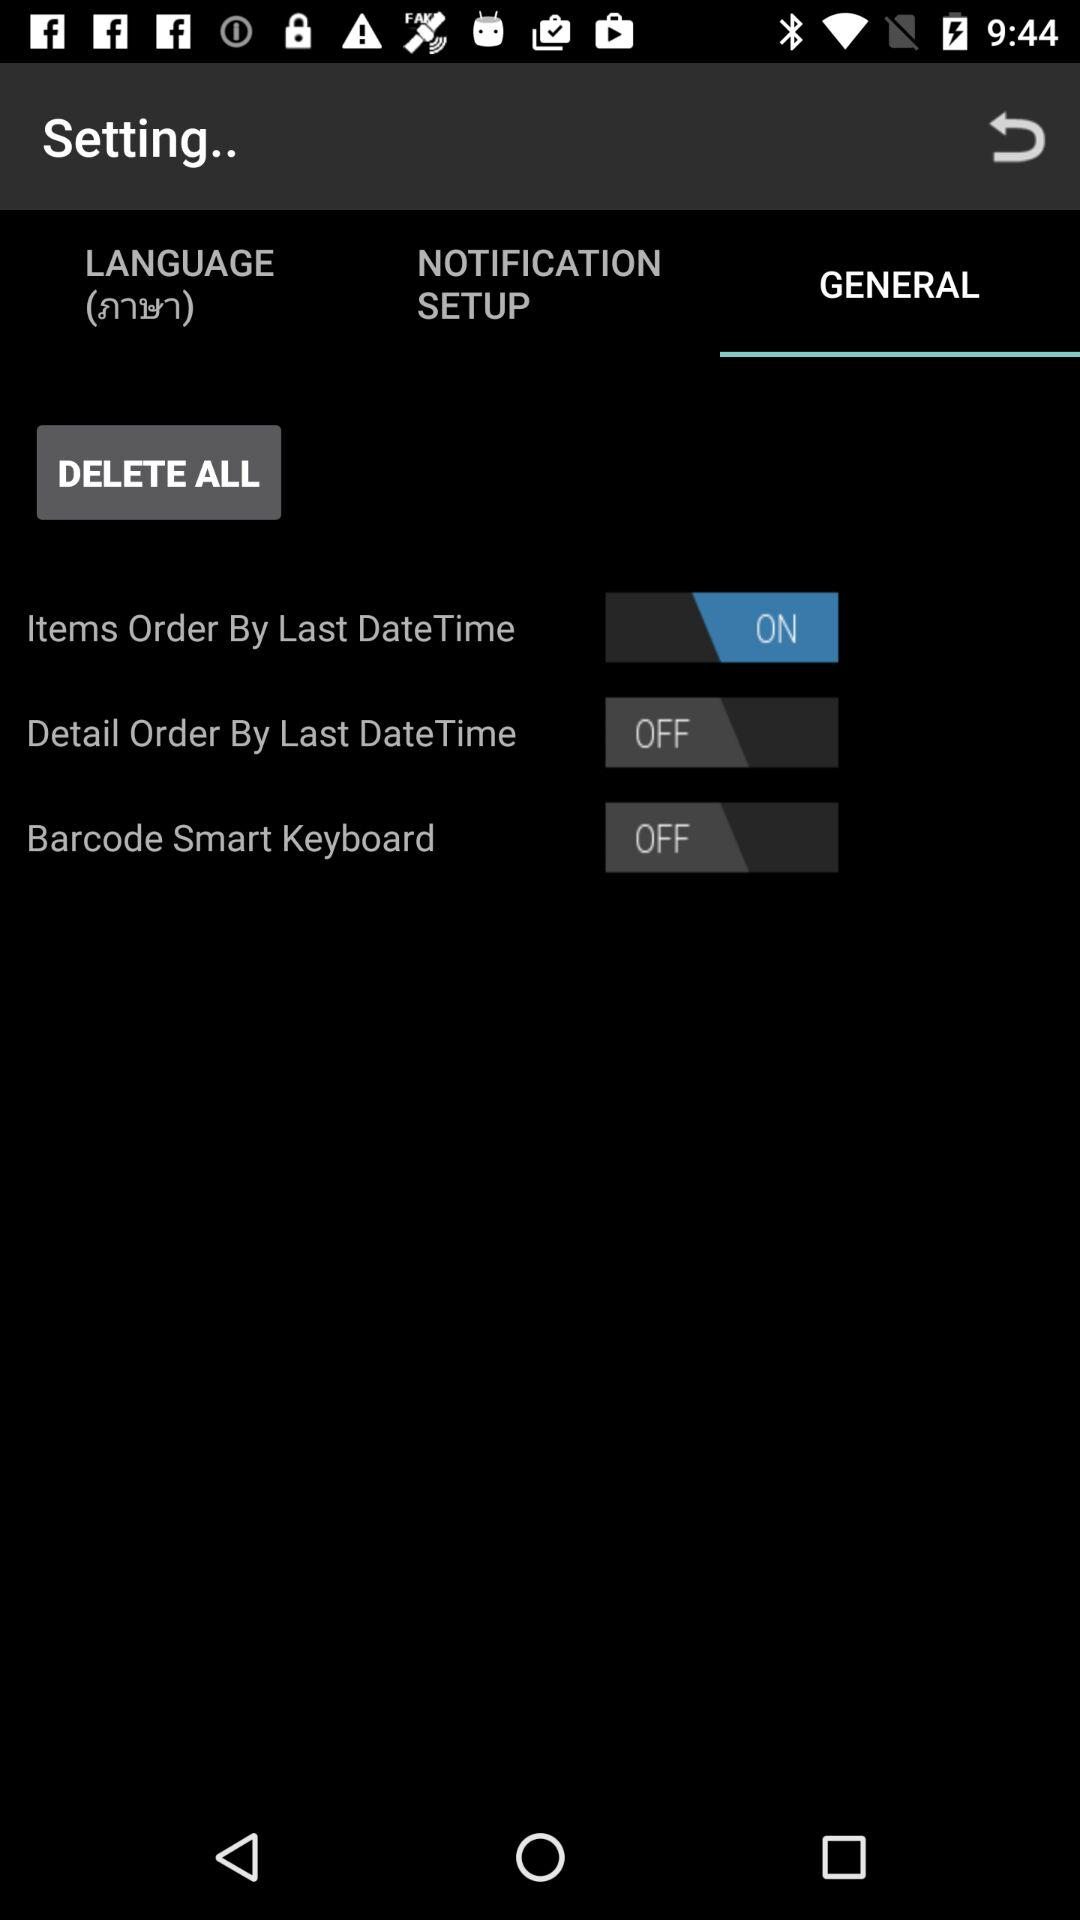Is "Barcode Smart Keyboard" on or off? "Barcode Smart Keyboard" is "off". 